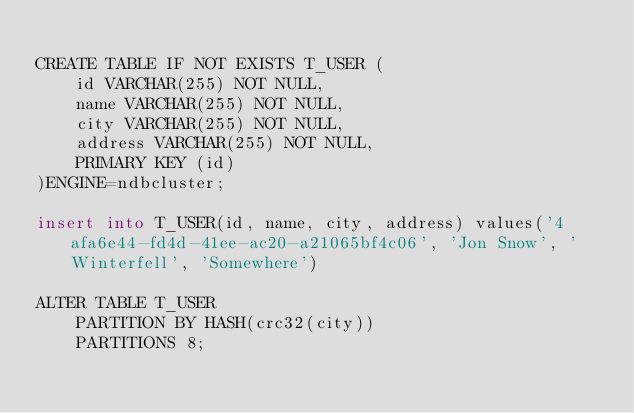Convert code to text. <code><loc_0><loc_0><loc_500><loc_500><_SQL_>
CREATE TABLE IF NOT EXISTS T_USER (
    id VARCHAR(255) NOT NULL,
    name VARCHAR(255) NOT NULL,
    city VARCHAR(255) NOT NULL,
    address VARCHAR(255) NOT NULL,
    PRIMARY KEY (id)
)ENGINE=ndbcluster;

insert into T_USER(id, name, city, address) values('4afa6e44-fd4d-41ee-ac20-a21065bf4c06', 'Jon Snow', 'Winterfell', 'Somewhere')

ALTER TABLE T_USER
    PARTITION BY HASH(crc32(city))
    PARTITIONS 8;

</code> 